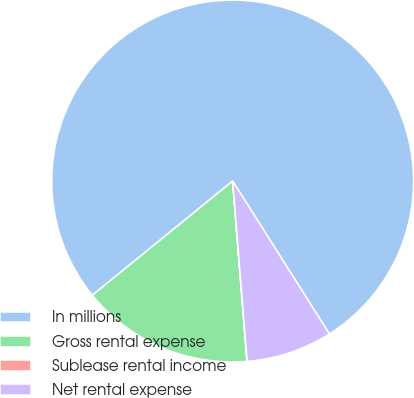Convert chart to OTSL. <chart><loc_0><loc_0><loc_500><loc_500><pie_chart><fcel>In millions<fcel>Gross rental expense<fcel>Sublease rental income<fcel>Net rental expense<nl><fcel>76.89%<fcel>15.39%<fcel>0.02%<fcel>7.7%<nl></chart> 